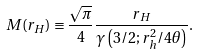Convert formula to latex. <formula><loc_0><loc_0><loc_500><loc_500>M ( r _ { H } ) \equiv \frac { \sqrt { \pi } } { 4 } \frac { r _ { H } } { \gamma \left ( 3 / 2 ; r _ { h } ^ { 2 } / 4 \theta \right ) } .</formula> 